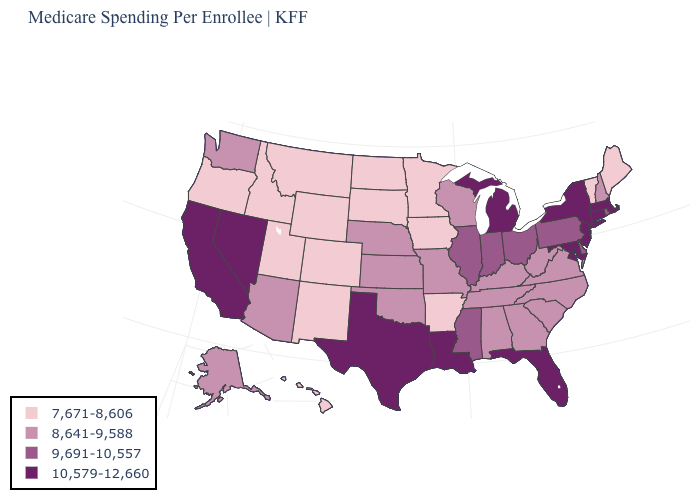Does New Mexico have the same value as Louisiana?
Concise answer only. No. What is the value of West Virginia?
Be succinct. 8,641-9,588. Is the legend a continuous bar?
Concise answer only. No. Which states have the lowest value in the USA?
Be succinct. Arkansas, Colorado, Hawaii, Idaho, Iowa, Maine, Minnesota, Montana, New Mexico, North Dakota, Oregon, South Dakota, Utah, Vermont, Wyoming. What is the value of Tennessee?
Write a very short answer. 8,641-9,588. Which states have the lowest value in the USA?
Be succinct. Arkansas, Colorado, Hawaii, Idaho, Iowa, Maine, Minnesota, Montana, New Mexico, North Dakota, Oregon, South Dakota, Utah, Vermont, Wyoming. Which states have the lowest value in the USA?
Quick response, please. Arkansas, Colorado, Hawaii, Idaho, Iowa, Maine, Minnesota, Montana, New Mexico, North Dakota, Oregon, South Dakota, Utah, Vermont, Wyoming. Name the states that have a value in the range 7,671-8,606?
Answer briefly. Arkansas, Colorado, Hawaii, Idaho, Iowa, Maine, Minnesota, Montana, New Mexico, North Dakota, Oregon, South Dakota, Utah, Vermont, Wyoming. Is the legend a continuous bar?
Short answer required. No. Name the states that have a value in the range 7,671-8,606?
Give a very brief answer. Arkansas, Colorado, Hawaii, Idaho, Iowa, Maine, Minnesota, Montana, New Mexico, North Dakota, Oregon, South Dakota, Utah, Vermont, Wyoming. Name the states that have a value in the range 8,641-9,588?
Concise answer only. Alabama, Alaska, Arizona, Georgia, Kansas, Kentucky, Missouri, Nebraska, New Hampshire, North Carolina, Oklahoma, South Carolina, Tennessee, Virginia, Washington, West Virginia, Wisconsin. What is the highest value in the USA?
Be succinct. 10,579-12,660. Name the states that have a value in the range 8,641-9,588?
Quick response, please. Alabama, Alaska, Arizona, Georgia, Kansas, Kentucky, Missouri, Nebraska, New Hampshire, North Carolina, Oklahoma, South Carolina, Tennessee, Virginia, Washington, West Virginia, Wisconsin. Is the legend a continuous bar?
Concise answer only. No. Does Tennessee have the highest value in the USA?
Keep it brief. No. 